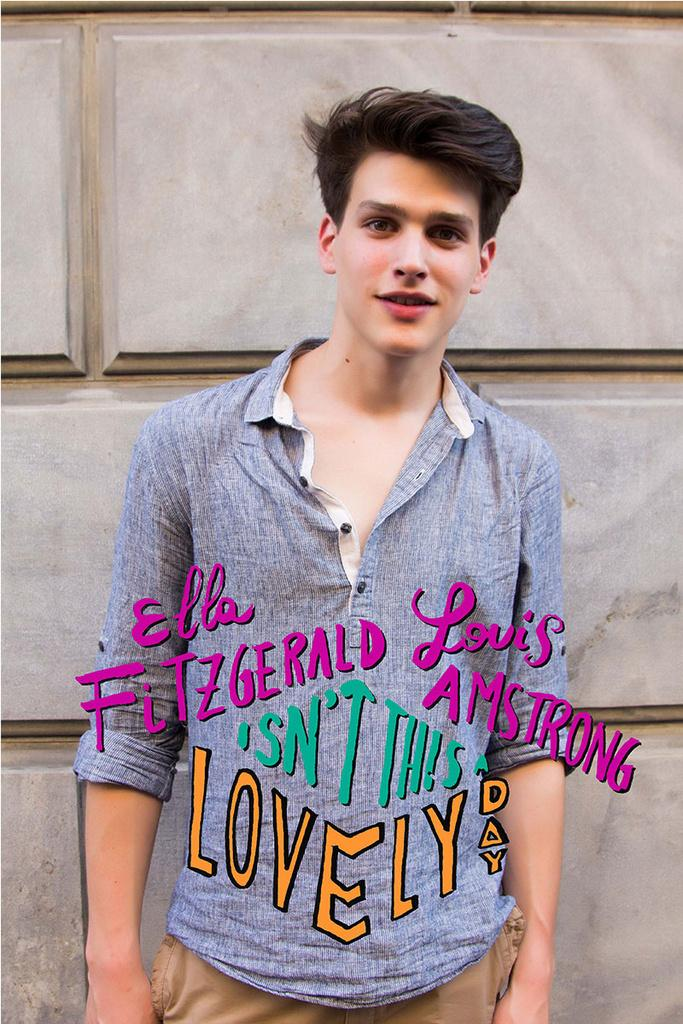Who is the main subject in the image? There is a man in the center of the image. What can be seen in the background of the image? There is a wall in the background of the image. What is located in the center of the image besides the man? There is some text in the center of the image. How much blood can be seen on the wall in the image? There is no blood present in the image, so it is not possible to determine a record for blood. 